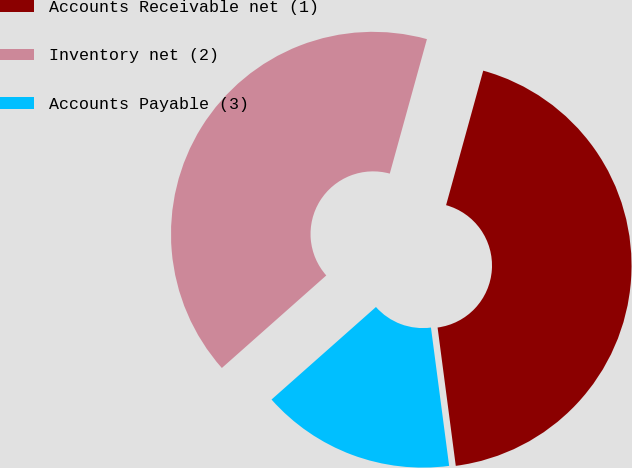<chart> <loc_0><loc_0><loc_500><loc_500><pie_chart><fcel>Accounts Receivable net (1)<fcel>Inventory net (2)<fcel>Accounts Payable (3)<nl><fcel>43.63%<fcel>40.83%<fcel>15.54%<nl></chart> 